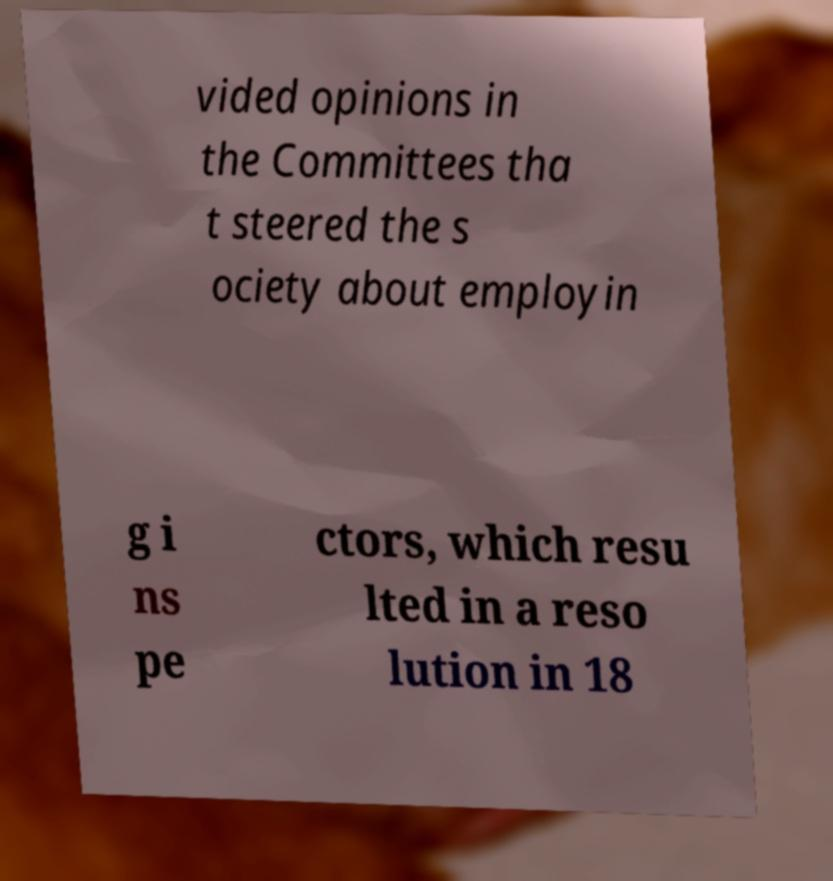Please identify and transcribe the text found in this image. vided opinions in the Committees tha t steered the s ociety about employin g i ns pe ctors, which resu lted in a reso lution in 18 